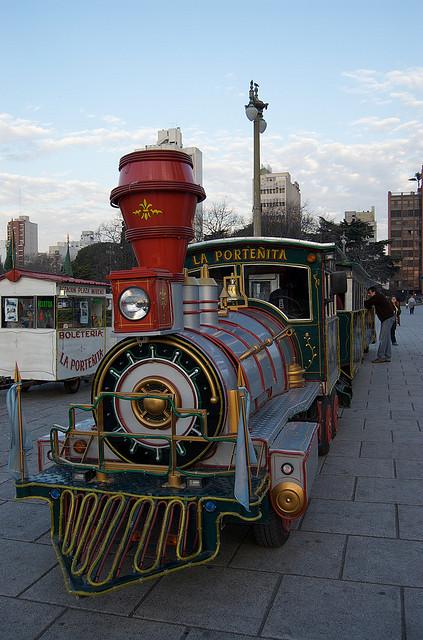Are there train tracks?
Give a very brief answer. No. What color is the sky?
Write a very short answer. Blue. Are the street lights on?
Write a very short answer. No. 